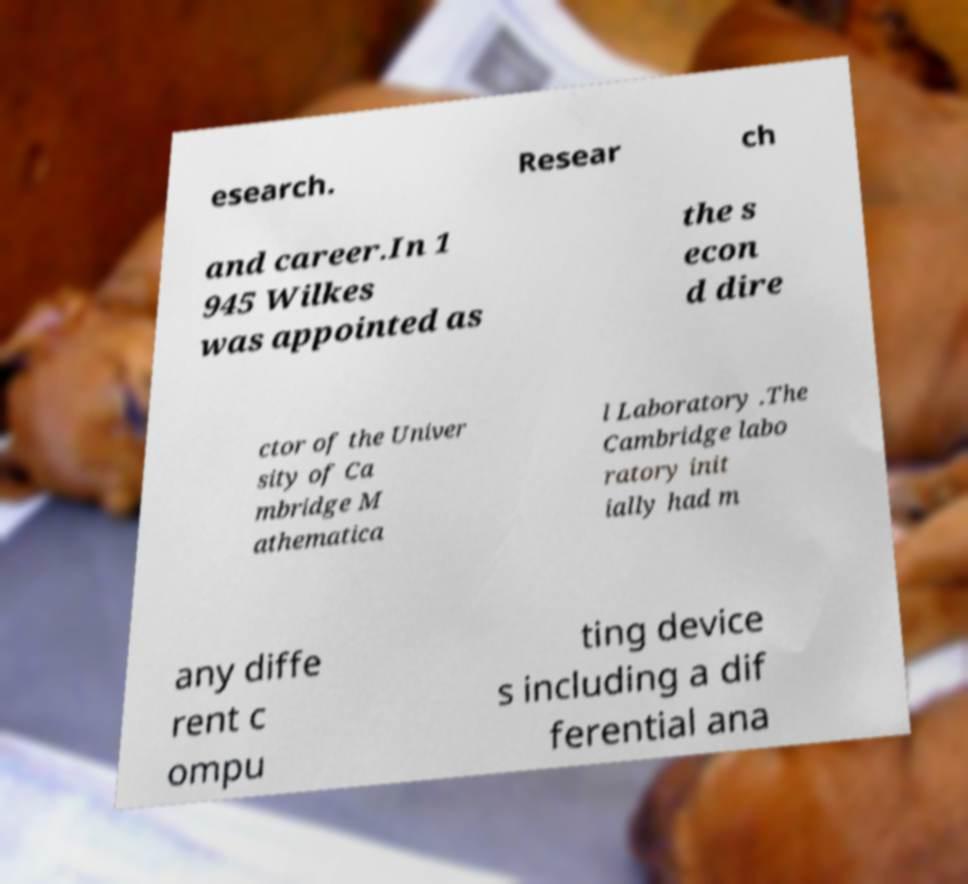Could you extract and type out the text from this image? esearch. Resear ch and career.In 1 945 Wilkes was appointed as the s econ d dire ctor of the Univer sity of Ca mbridge M athematica l Laboratory .The Cambridge labo ratory init ially had m any diffe rent c ompu ting device s including a dif ferential ana 